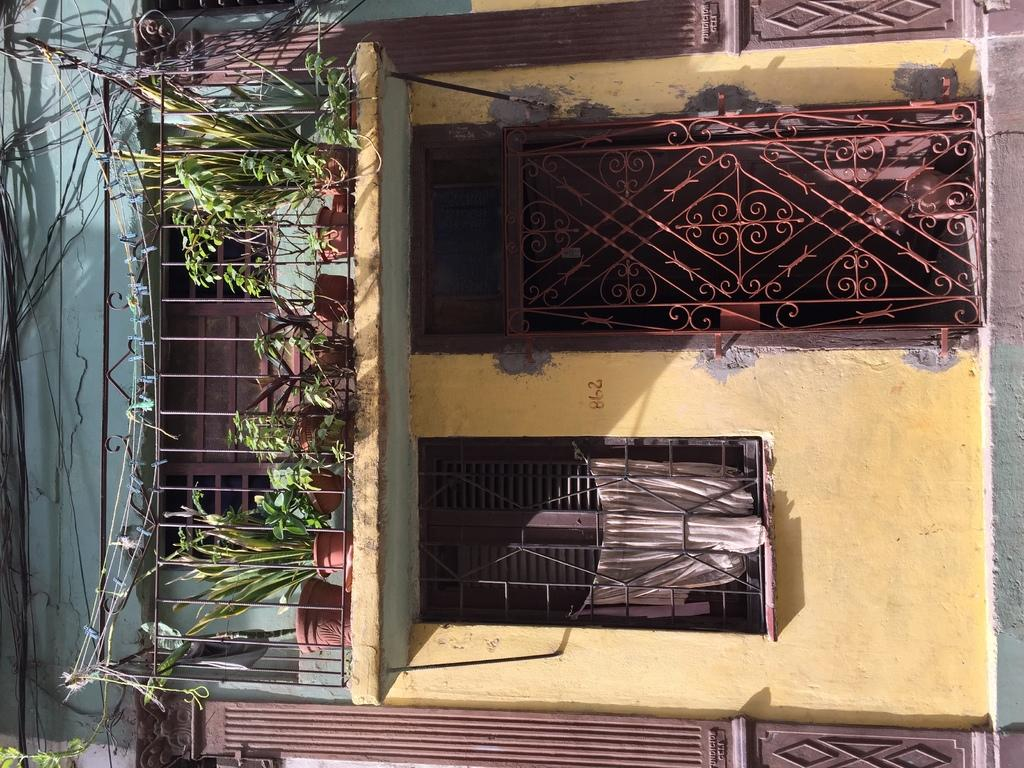What type of structure is visible in the image? There is a building in the image. What can be seen in the center of the image? There are plants and a window in the center of the image. Is there any entrance visible in the image? Yes, there is a door in the center of the image. What else can be seen on the left side of the image? There are cables on the left side of the image. How does the servant assist the residents of the building in the image? There is no servant present in the image, so it is not possible to answer that question. 